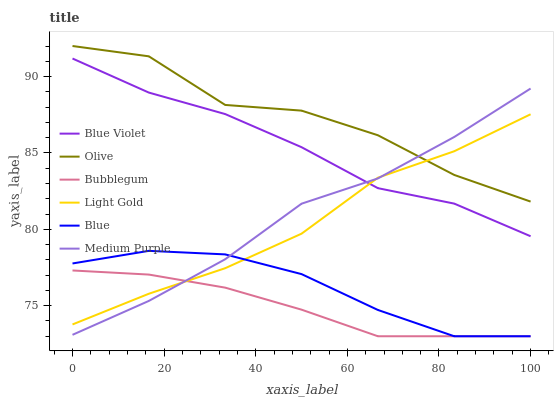Does Bubblegum have the minimum area under the curve?
Answer yes or no. Yes. Does Olive have the maximum area under the curve?
Answer yes or no. Yes. Does Medium Purple have the minimum area under the curve?
Answer yes or no. No. Does Medium Purple have the maximum area under the curve?
Answer yes or no. No. Is Bubblegum the smoothest?
Answer yes or no. Yes. Is Olive the roughest?
Answer yes or no. Yes. Is Medium Purple the smoothest?
Answer yes or no. No. Is Medium Purple the roughest?
Answer yes or no. No. Does Blue have the lowest value?
Answer yes or no. Yes. Does Medium Purple have the lowest value?
Answer yes or no. No. Does Olive have the highest value?
Answer yes or no. Yes. Does Medium Purple have the highest value?
Answer yes or no. No. Is Bubblegum less than Blue Violet?
Answer yes or no. Yes. Is Olive greater than Blue?
Answer yes or no. Yes. Does Bubblegum intersect Blue?
Answer yes or no. Yes. Is Bubblegum less than Blue?
Answer yes or no. No. Is Bubblegum greater than Blue?
Answer yes or no. No. Does Bubblegum intersect Blue Violet?
Answer yes or no. No. 